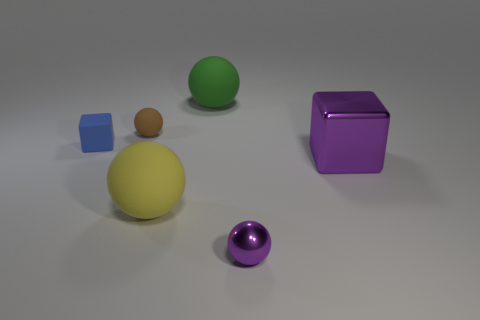Subtract 1 balls. How many balls are left? 3 Subtract all gray spheres. Subtract all yellow cylinders. How many spheres are left? 4 Add 2 big blue shiny objects. How many objects exist? 8 Subtract all cubes. How many objects are left? 4 Add 2 large rubber spheres. How many large rubber spheres exist? 4 Subtract 0 cyan cylinders. How many objects are left? 6 Subtract all metallic things. Subtract all tiny gray matte cubes. How many objects are left? 4 Add 5 tiny purple spheres. How many tiny purple spheres are left? 6 